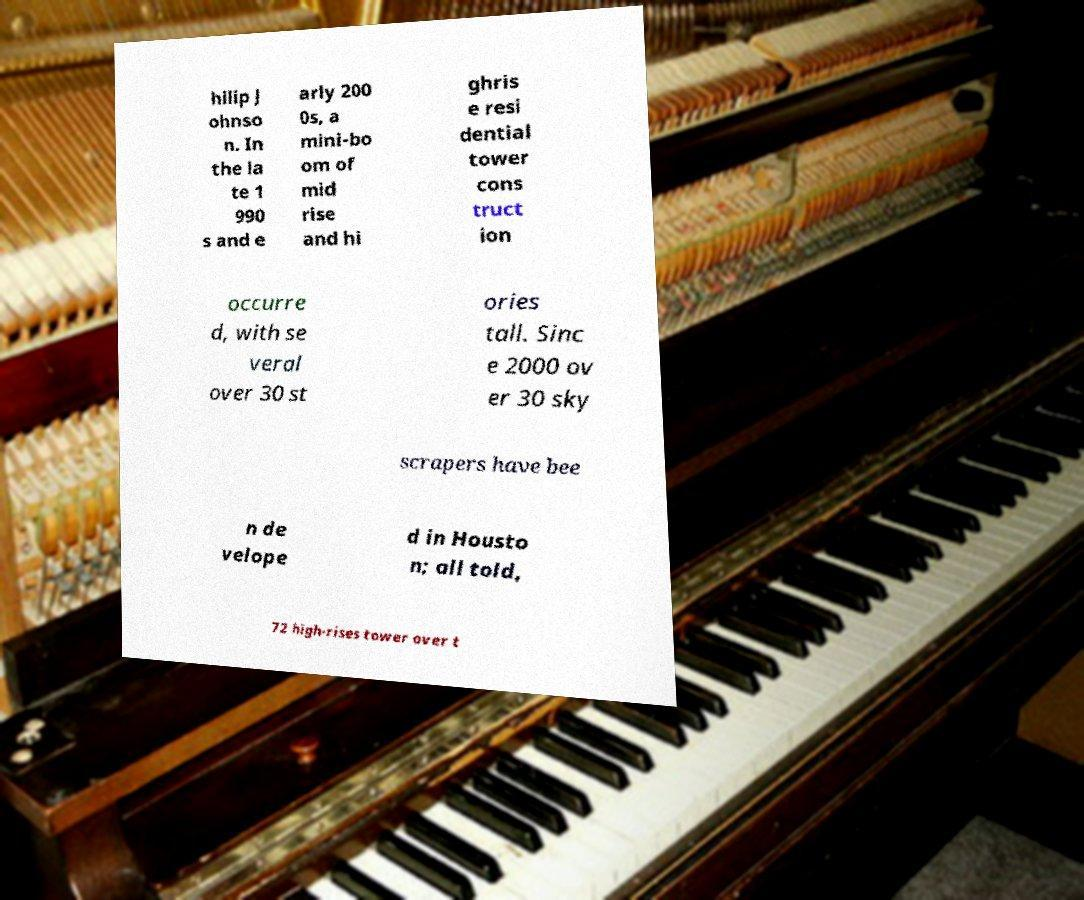What messages or text are displayed in this image? I need them in a readable, typed format. hilip J ohnso n. In the la te 1 990 s and e arly 200 0s, a mini-bo om of mid rise and hi ghris e resi dential tower cons truct ion occurre d, with se veral over 30 st ories tall. Sinc e 2000 ov er 30 sky scrapers have bee n de velope d in Housto n; all told, 72 high-rises tower over t 